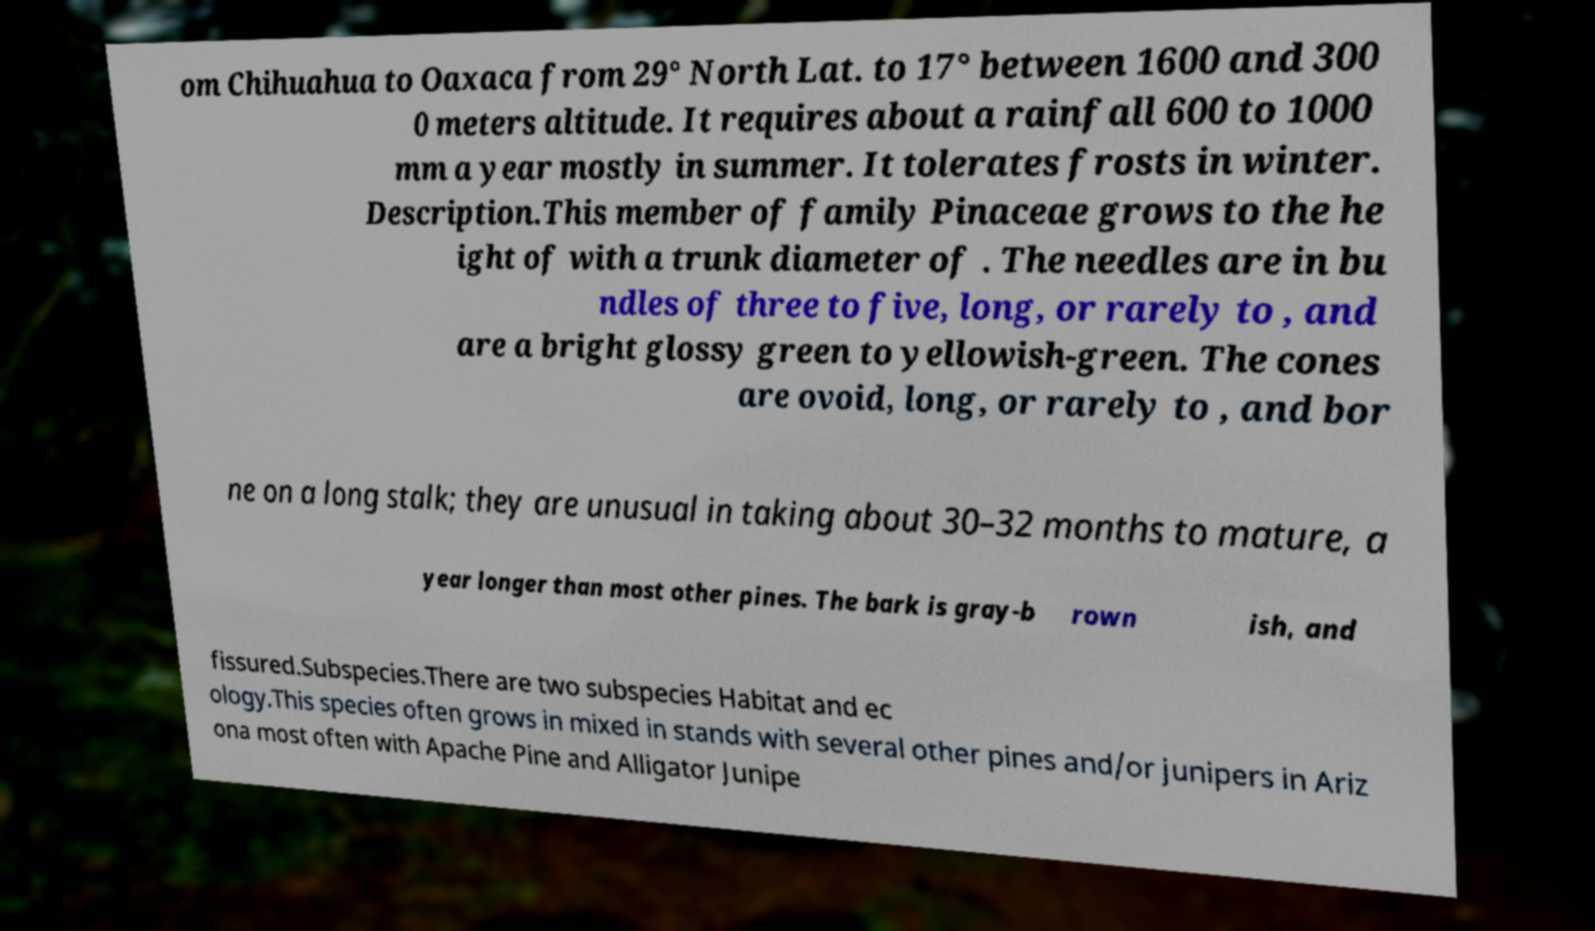What messages or text are displayed in this image? I need them in a readable, typed format. om Chihuahua to Oaxaca from 29° North Lat. to 17° between 1600 and 300 0 meters altitude. It requires about a rainfall 600 to 1000 mm a year mostly in summer. It tolerates frosts in winter. Description.This member of family Pinaceae grows to the he ight of with a trunk diameter of . The needles are in bu ndles of three to five, long, or rarely to , and are a bright glossy green to yellowish-green. The cones are ovoid, long, or rarely to , and bor ne on a long stalk; they are unusual in taking about 30–32 months to mature, a year longer than most other pines. The bark is gray-b rown ish, and fissured.Subspecies.There are two subspecies Habitat and ec ology.This species often grows in mixed in stands with several other pines and/or junipers in Ariz ona most often with Apache Pine and Alligator Junipe 